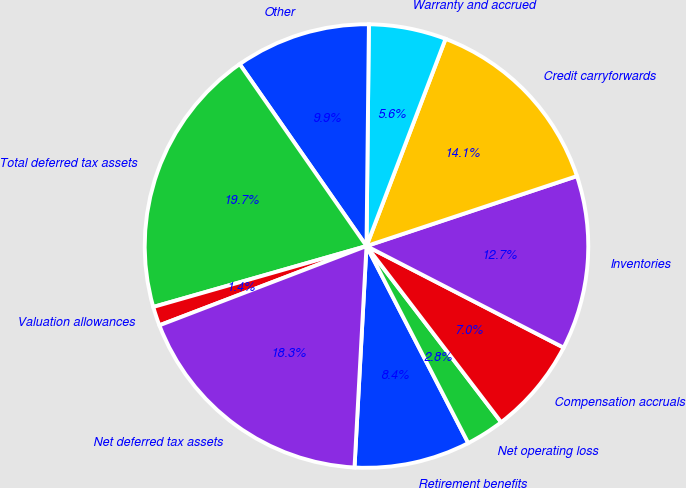<chart> <loc_0><loc_0><loc_500><loc_500><pie_chart><fcel>Retirement benefits<fcel>Net operating loss<fcel>Compensation accruals<fcel>Inventories<fcel>Credit carryforwards<fcel>Warranty and accrued<fcel>Other<fcel>Total deferred tax assets<fcel>Valuation allowances<fcel>Net deferred tax assets<nl><fcel>8.45%<fcel>2.8%<fcel>7.04%<fcel>12.68%<fcel>14.09%<fcel>5.63%<fcel>9.86%<fcel>19.74%<fcel>1.39%<fcel>18.32%<nl></chart> 